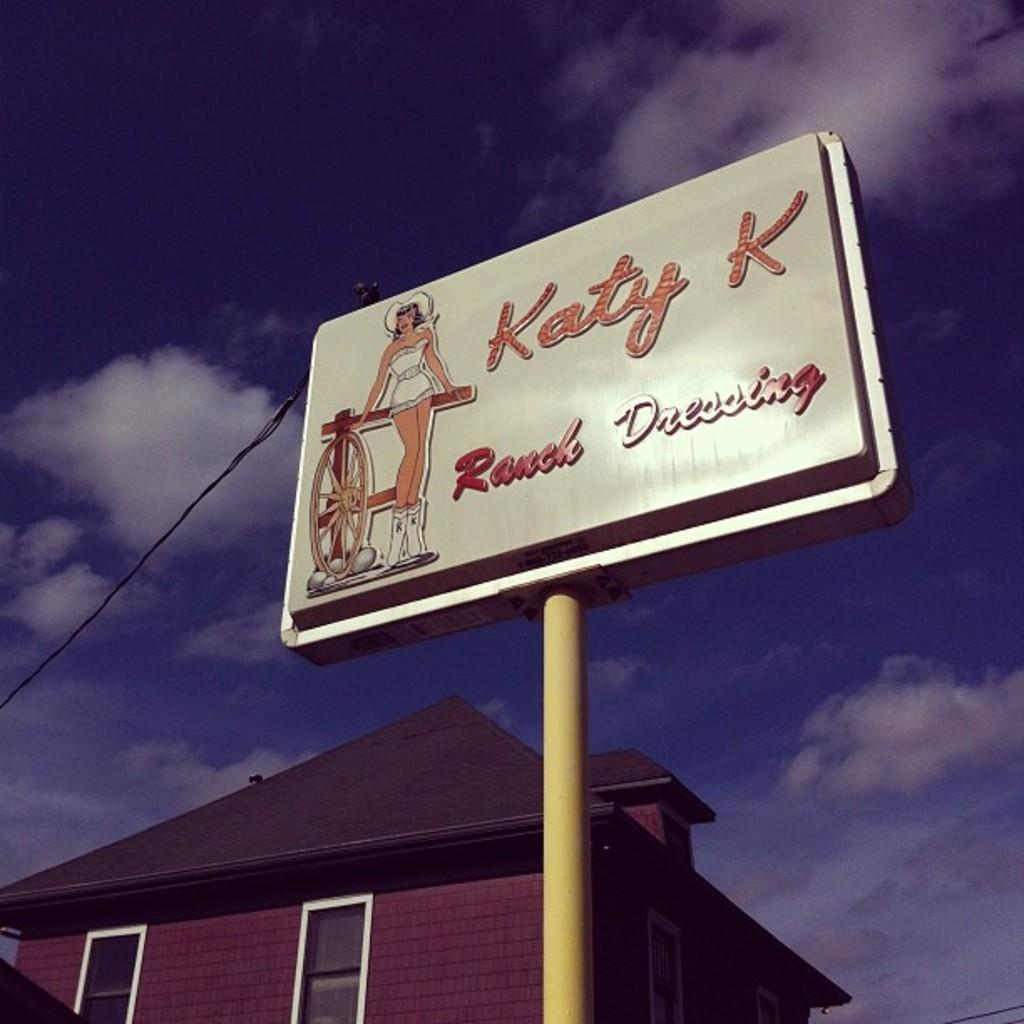<image>
Relay a brief, clear account of the picture shown. A store sign for KATY K Ranch dressing on a pole 